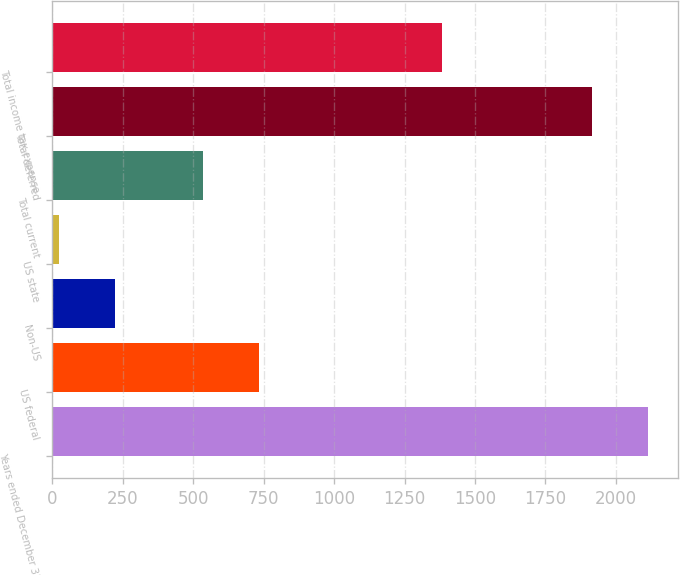<chart> <loc_0><loc_0><loc_500><loc_500><bar_chart><fcel>Years ended December 31<fcel>US federal<fcel>Non-US<fcel>US state<fcel>Total current<fcel>Total deferred<fcel>Total income tax expense<nl><fcel>2114.9<fcel>732.9<fcel>220.9<fcel>22<fcel>534<fcel>1916<fcel>1382<nl></chart> 